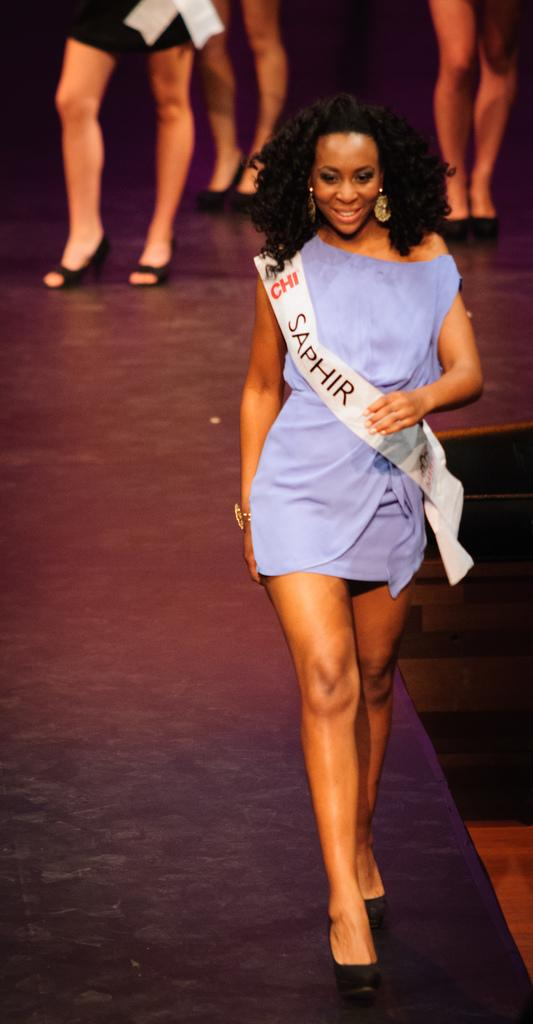<image>
Create a compact narrative representing the image presented. a runway model wearing a Saphir banner across her purple mini dress 